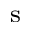Convert formula to latex. <formula><loc_0><loc_0><loc_500><loc_500>_ { s }</formula> 